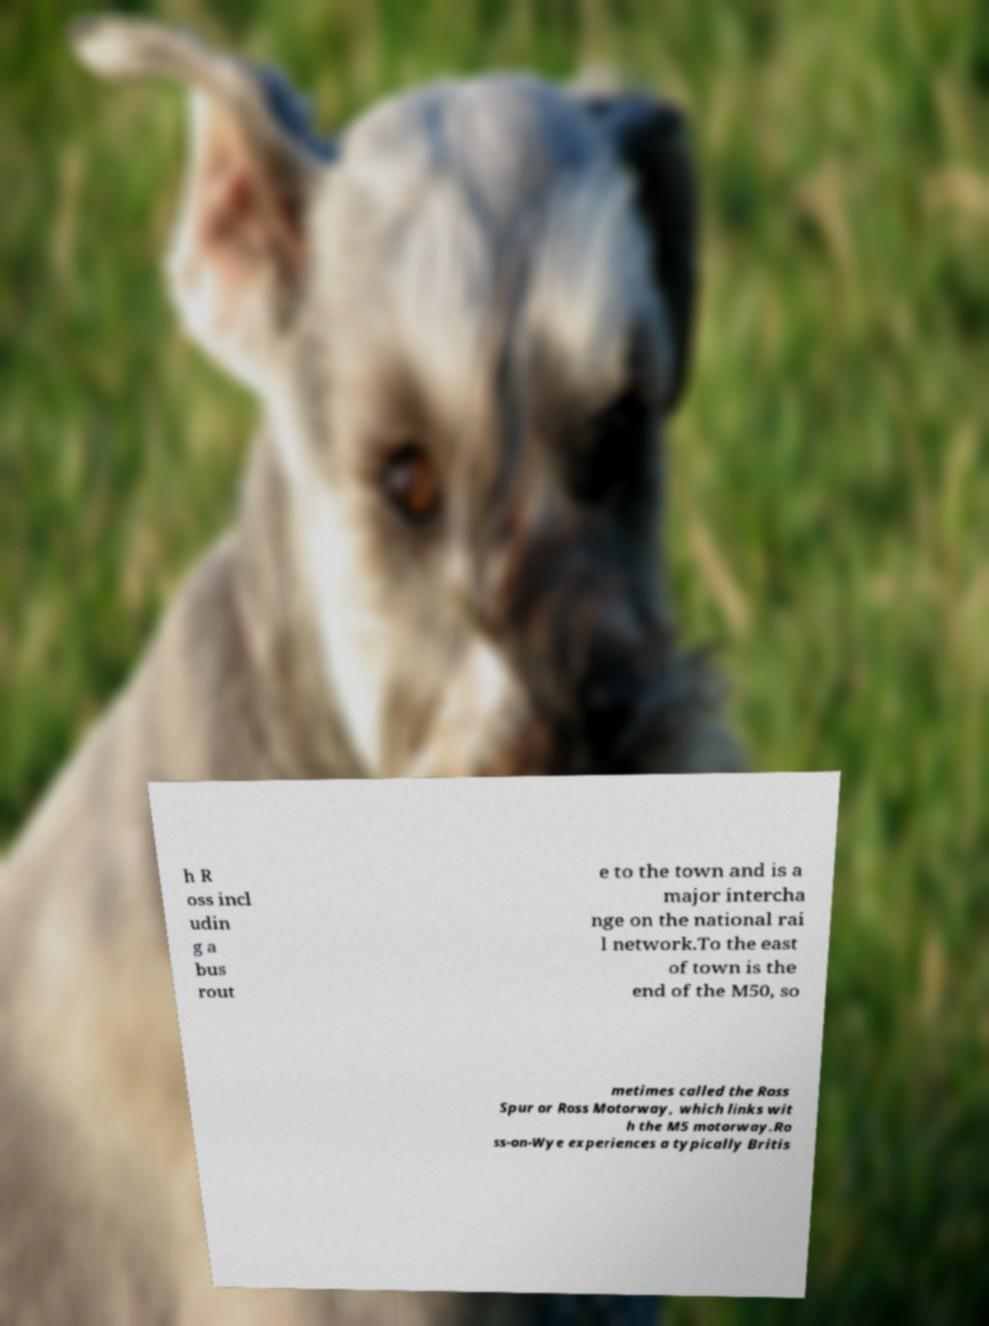For documentation purposes, I need the text within this image transcribed. Could you provide that? h R oss incl udin g a bus rout e to the town and is a major intercha nge on the national rai l network.To the east of town is the end of the M50, so metimes called the Ross Spur or Ross Motorway, which links wit h the M5 motorway.Ro ss-on-Wye experiences a typically Britis 